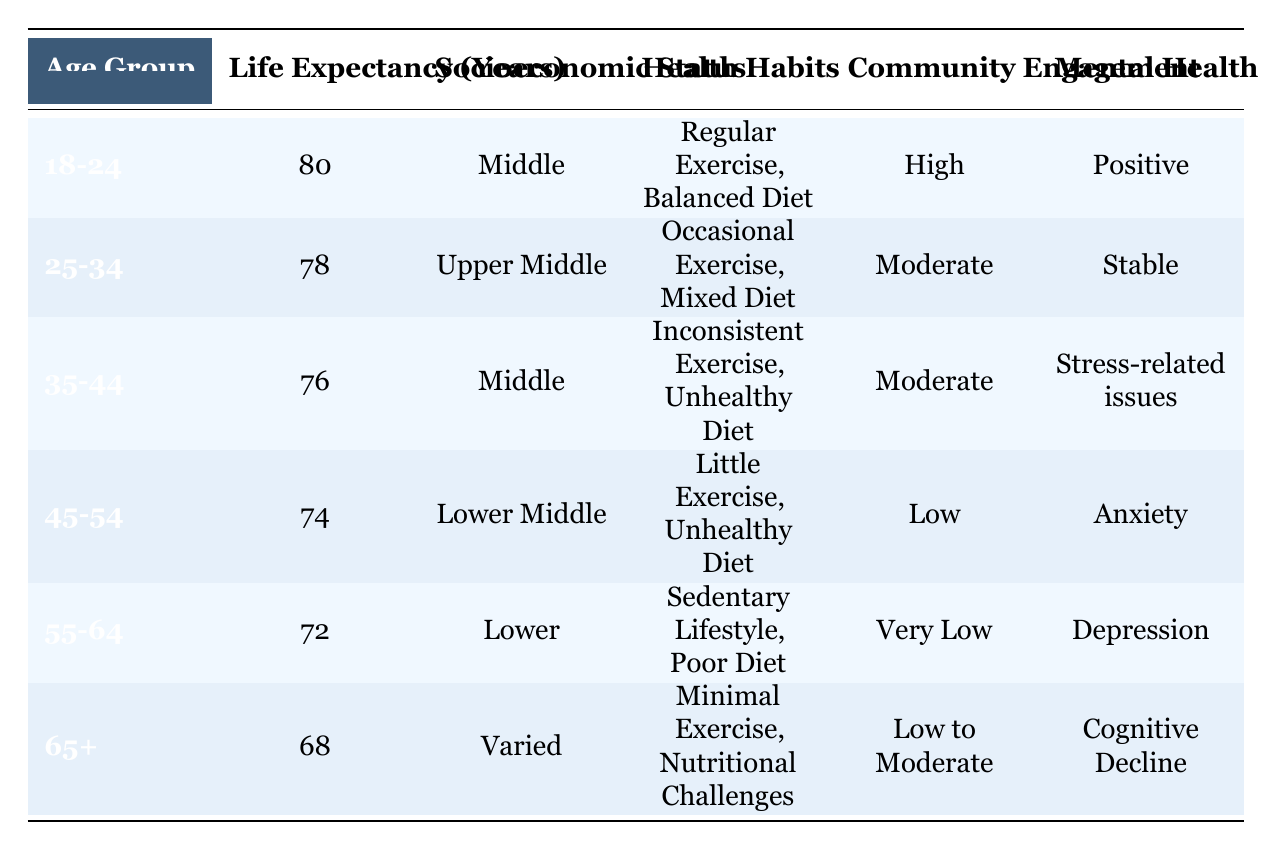What is the life expectancy for the age group 45-54? The table lists the life expectancy for each age group. Looking specifically at the row for the age group 45-54, we can see that the life expectancy is 74 years.
Answer: 74 What is the socioeconomic status of the 55-64 age group? By examining the row for the 55-64 age group in the table, we can see that their socioeconomic status is categorized as 'Lower.'
Answer: Lower Is the health habit of the 18-24 age group regular exercise? In the 18-24 age group's row, it states that their health habits include 'Regular Exercise, Balanced Diet.' Therefore, the statement is true.
Answer: Yes What is the average life expectancy of attendees aged 35-44 and 45-54? We need to find the life expectancy for both age groups. For 35-44, it is 76 years, and for 45-54, it is 74 years. The average is calculated as (76 + 74) / 2 = 75.
Answer: 75 How many age groups reported a positive mental health status? From the table, only the 18-24 age group has 'Positive' listed under mental health. The other age groups have different statuses, thus confirming only one group with positive mental health.
Answer: 1 Does the 25-34 age group engage more in community activities than the 55-64 age group? Looking at the community engagement column, the 25-34 age group is described as 'Moderate' while the 55-64 age group is marked as 'Very Low.' This means the 25-34 age group engages more in community activities.
Answer: Yes What is the difference in life expectancy between the 18-24 group and the 65+ group? The life expectancy for the 18-24 age group is 80 years, and for the 65+ age group, it is 68 years. Thus, the difference is calculated as 80 - 68 = 12 years.
Answer: 12 Which age group has the lowest level of community engagement? By reviewing the community engagement descriptions, the age group 55-64 has 'Very Low' listed, which is the lowest compared to others.
Answer: 55-64 What are the health habits for the age group 35-44? The table specifies that for the 35-44 age group, their health habits consist of 'Inconsistent Exercise, Unhealthy Diet.'
Answer: Inconsistent Exercise, Unhealthy Diet 